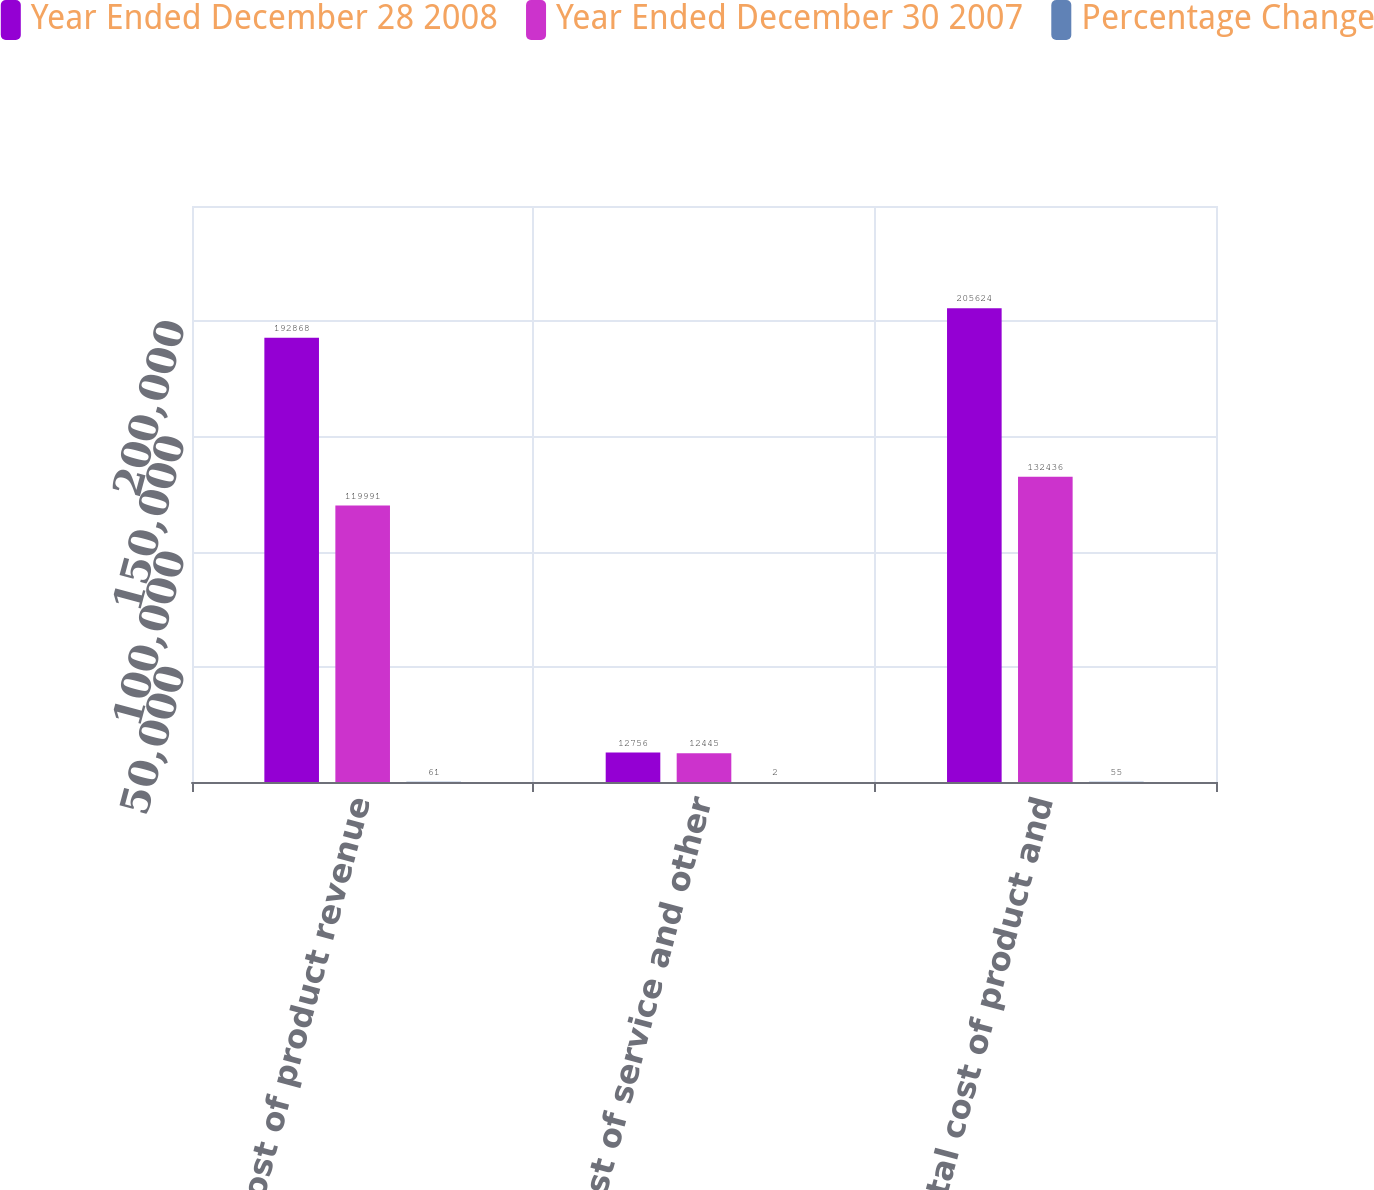Convert chart to OTSL. <chart><loc_0><loc_0><loc_500><loc_500><stacked_bar_chart><ecel><fcel>Cost of product revenue<fcel>Cost of service and other<fcel>Total cost of product and<nl><fcel>Year Ended December 28 2008<fcel>192868<fcel>12756<fcel>205624<nl><fcel>Year Ended December 30 2007<fcel>119991<fcel>12445<fcel>132436<nl><fcel>Percentage Change<fcel>61<fcel>2<fcel>55<nl></chart> 